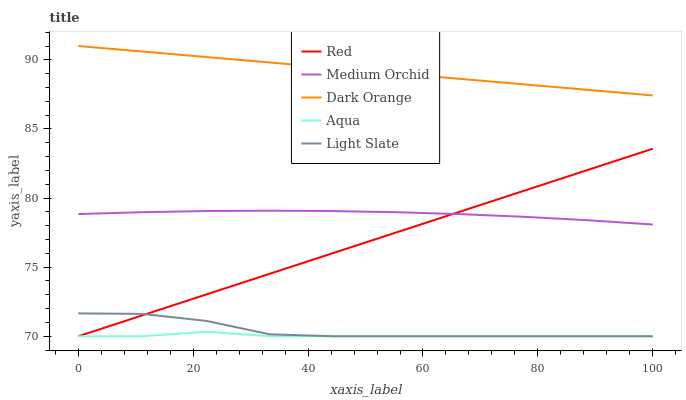Does Aqua have the minimum area under the curve?
Answer yes or no. Yes. Does Dark Orange have the maximum area under the curve?
Answer yes or no. Yes. Does Medium Orchid have the minimum area under the curve?
Answer yes or no. No. Does Medium Orchid have the maximum area under the curve?
Answer yes or no. No. Is Red the smoothest?
Answer yes or no. Yes. Is Light Slate the roughest?
Answer yes or no. Yes. Is Dark Orange the smoothest?
Answer yes or no. No. Is Dark Orange the roughest?
Answer yes or no. No. Does Medium Orchid have the lowest value?
Answer yes or no. No. Does Dark Orange have the highest value?
Answer yes or no. Yes. Does Medium Orchid have the highest value?
Answer yes or no. No. Is Medium Orchid less than Dark Orange?
Answer yes or no. Yes. Is Dark Orange greater than Red?
Answer yes or no. Yes. Does Medium Orchid intersect Red?
Answer yes or no. Yes. Is Medium Orchid less than Red?
Answer yes or no. No. Is Medium Orchid greater than Red?
Answer yes or no. No. Does Medium Orchid intersect Dark Orange?
Answer yes or no. No. 